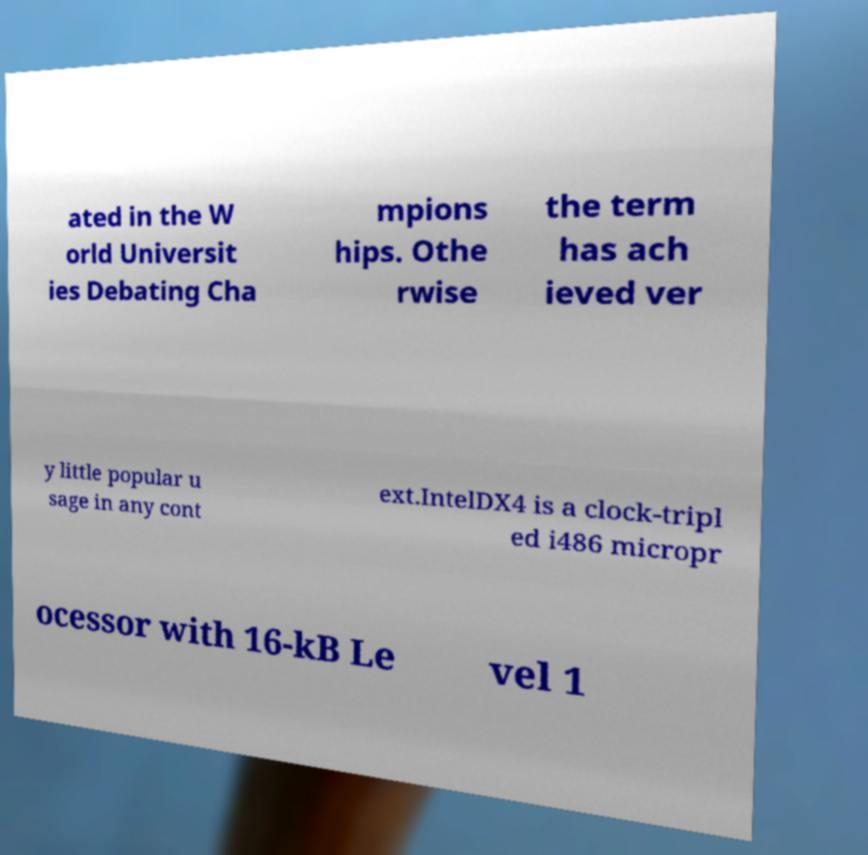I need the written content from this picture converted into text. Can you do that? ated in the W orld Universit ies Debating Cha mpions hips. Othe rwise the term has ach ieved ver y little popular u sage in any cont ext.IntelDX4 is a clock-tripl ed i486 micropr ocessor with 16-kB Le vel 1 